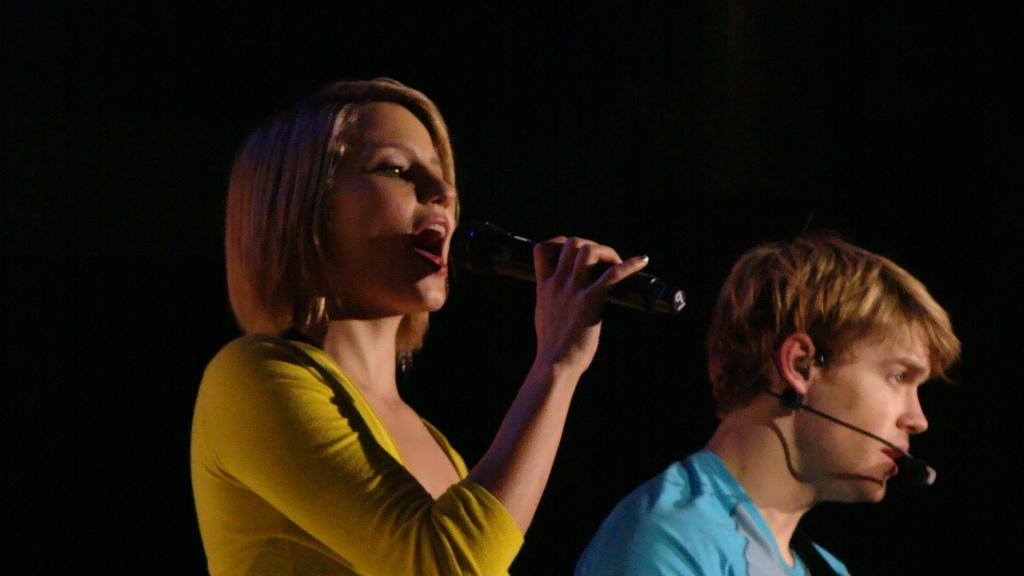What is the woman in the image doing? The woman is singing in the image. What is the woman using to amplify her voice? The woman is using a mic in the image. Can you describe the man's position in relation to the woman? The man is standing beside the woman in the image. What is the man using in the image? The man is using a mic in the image. What type of farmer is present in the image? There is no farmer present in the image. Where is the place located that the woman and man are performing at? The provided facts do not mention a specific place where the woman and man are performing. 